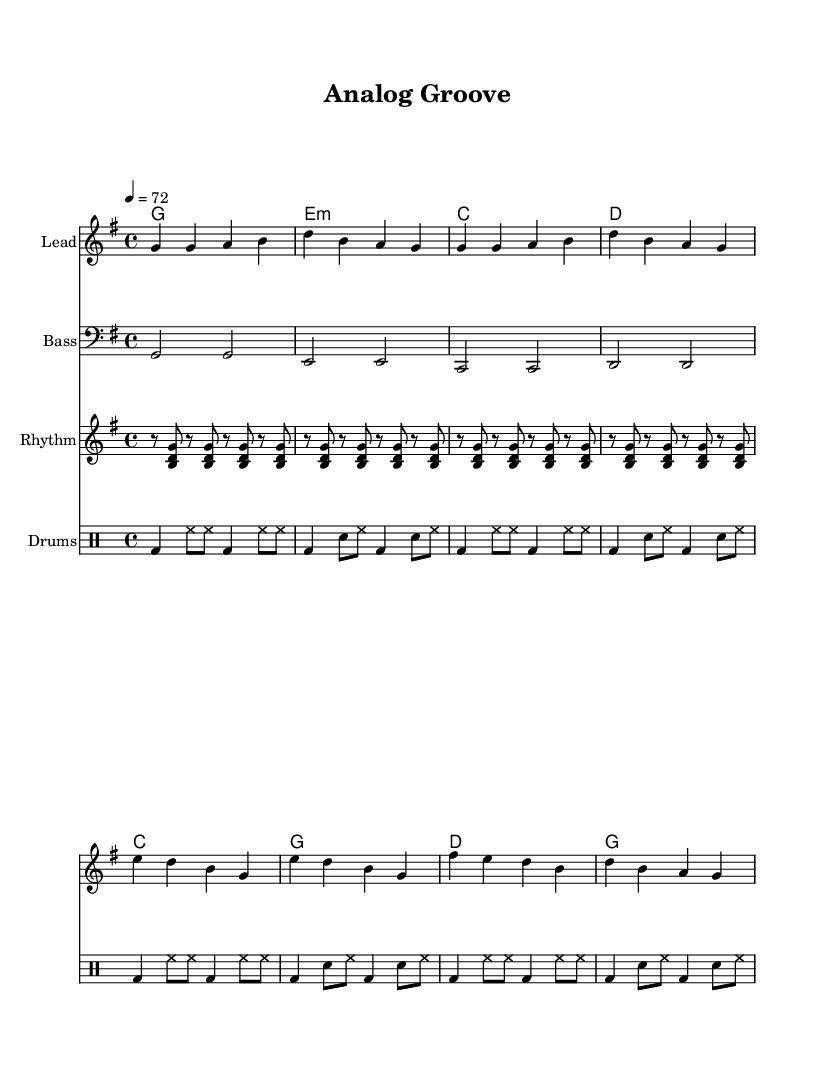What is the key signature of this music? The key signature is G major, which has one sharp (F#). You can determine this by looking at the key signature indication at the beginning of the score.
Answer: G major What is the time signature of the piece? The time signature is 4/4, which means there are four beats in a measure and a quarter note gets one beat. This is also indicated at the beginning of the sheet music.
Answer: 4/4 What is the tempo marking of the piece? The tempo marking is 72 beats per minute, noted at the beginning of the score. This indicates how fast the piece should be played.
Answer: 72 What are the two main sections of this song? The song consists of two sections: the verse and the chorus, which can be identified by looking at the musical phrases in the score. The melodyVerse and melodyChorus labels also indicate these sections.
Answer: Verse and Chorus How many times does the rhythm guitar repeat its phrase in the score? The rhythm guitar part repeats its four-bar phrase four times, as indicated in the notation with a repeat symbol and the word 'unfold.' This indicates that the phrase should be played continuously over the stated duration.
Answer: Four What chord follows the E minor chord in the progression? The chord that follows the E minor chord (e1:m) in the chord progression is C major (c1). You can find this by reading the chords from left to right in the chordNames section.
Answer: C major What is the instrument name for the staff representing the bass line? The instrument name for the staff representing the bass line is "Bass," which is labeled at the beginning of that particular staff in the sheet music.
Answer: Bass 